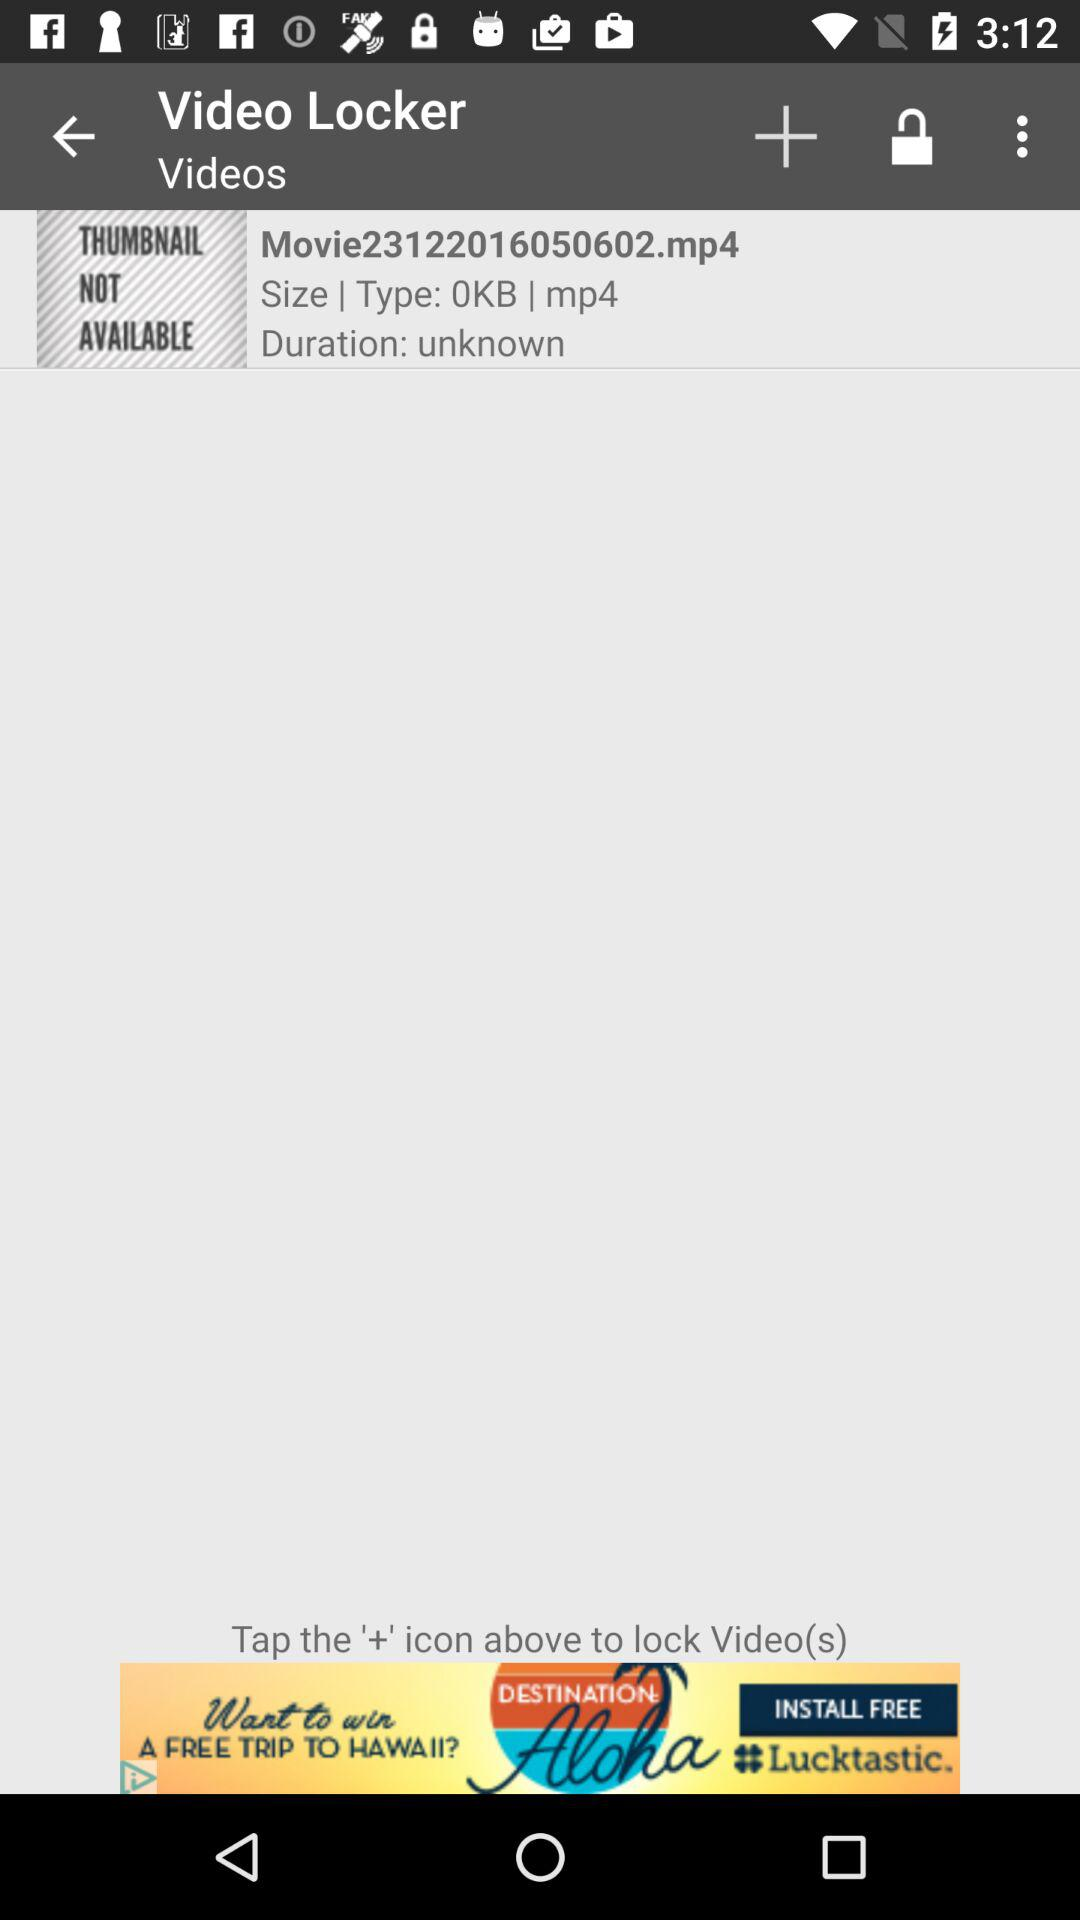How many video files are in the Video Locker?
Answer the question using a single word or phrase. 1 